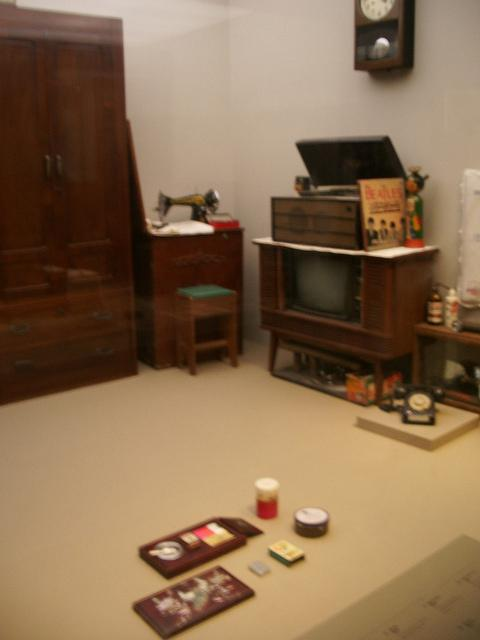What is able to be repaired by the machine in the corner? fabric 